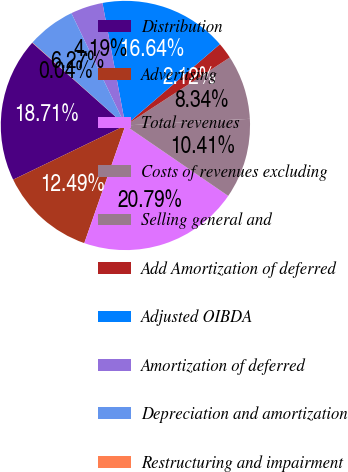Convert chart to OTSL. <chart><loc_0><loc_0><loc_500><loc_500><pie_chart><fcel>Distribution<fcel>Advertising<fcel>Total revenues<fcel>Costs of revenues excluding<fcel>Selling general and<fcel>Add Amortization of deferred<fcel>Adjusted OIBDA<fcel>Amortization of deferred<fcel>Depreciation and amortization<fcel>Restructuring and impairment<nl><fcel>18.71%<fcel>12.49%<fcel>20.79%<fcel>10.41%<fcel>8.34%<fcel>2.12%<fcel>16.64%<fcel>4.19%<fcel>6.27%<fcel>0.04%<nl></chart> 